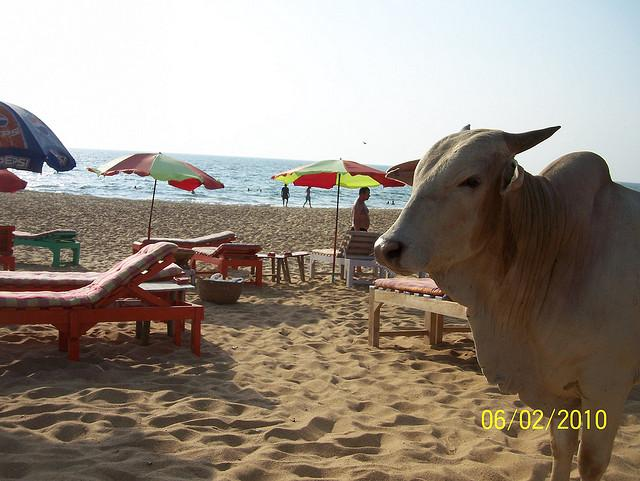Which sentient beings are able to swim?

Choices:
A) bugs
B) humans
C) goat
D) birds humans 